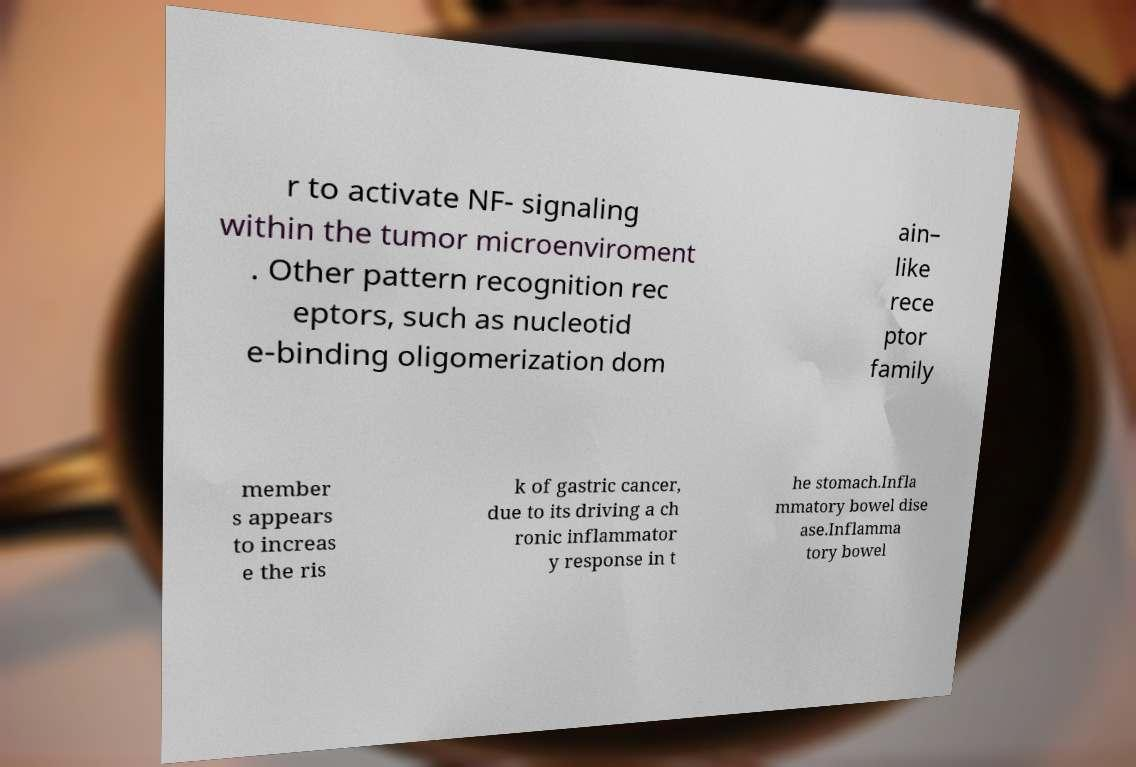Can you accurately transcribe the text from the provided image for me? r to activate NF- signaling within the tumor microenviroment . Other pattern recognition rec eptors, such as nucleotid e-binding oligomerization dom ain– like rece ptor family member s appears to increas e the ris k of gastric cancer, due to its driving a ch ronic inflammator y response in t he stomach.Infla mmatory bowel dise ase.Inflamma tory bowel 